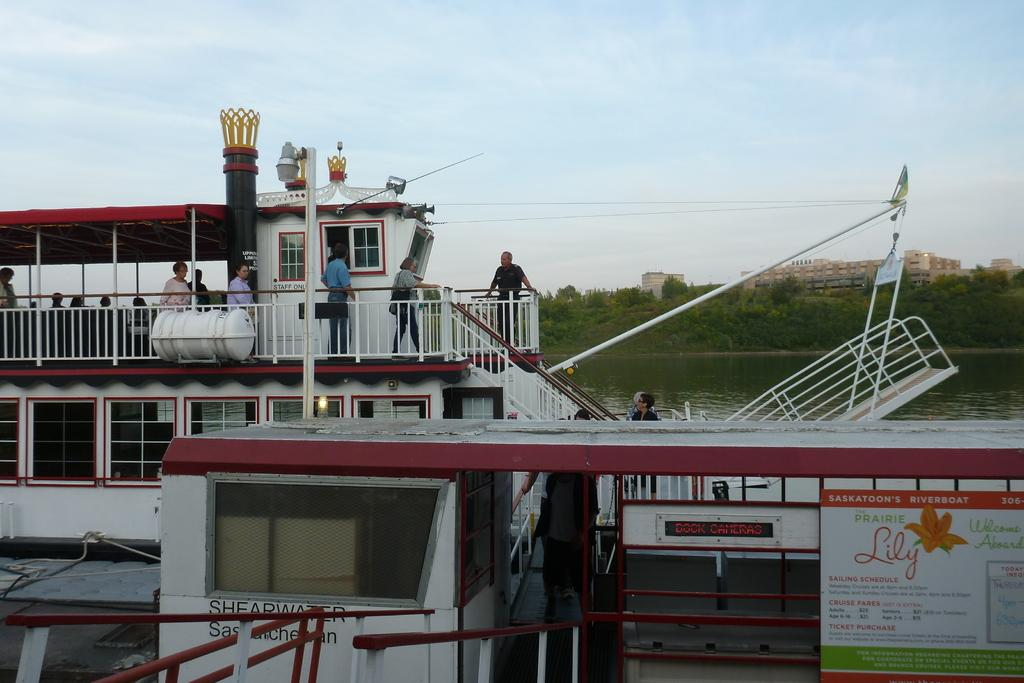What is the main subject of the image? The main subject of the image is a ship. What features can be seen on the ship? The ship has stairs and fencing. Are there any people on the ship? Yes, there are people present on the ship. What is visible in the background of the image? There are trees and buildings in the background of the image. What type of skirt is the ship wearing in the image? Ships do not wear skirts, as they are inanimate objects. --- Facts: 1. There is a car in the image. 2. The car is red. 3. The car has four wheels. 4. There are people in the car. 5. The car has a sunroof. 6. The car is parked on the street. Absurd Topics: parrot, sandcastle, volcano Conversation: What is the main subject of the image? The main subject of the image is a car. What color is the car? The car is red. How many wheels does the car have? The car has four wheels. Are there any people inside the car? Yes, there are people in the car. What feature does the car have that allows for an open-air experience? The car has a sunroof. Where is the car located in the image? The car is parked on the street. Reasoning: Let's think step by step in order to produce the conversation. We start by identifying the main subject of the image, which is the car. Then, we describe specific features of the car, such as its color, number of wheels, and the presence of people inside. Next, we mention a unique feature of the car, the sunroof. Finally, we describe the car's location in the image, which is parked on the street. Absurd Question/Answer: Can you see a parrot building a sandcastle near the volcano in the image? There is no parrot, sandcastle, or volcano present in the image. 